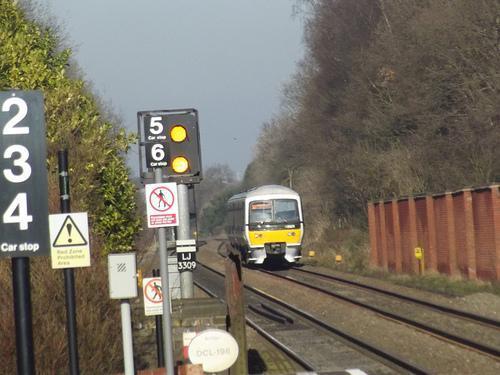How many trains are there in the picture?
Give a very brief answer. 1. 